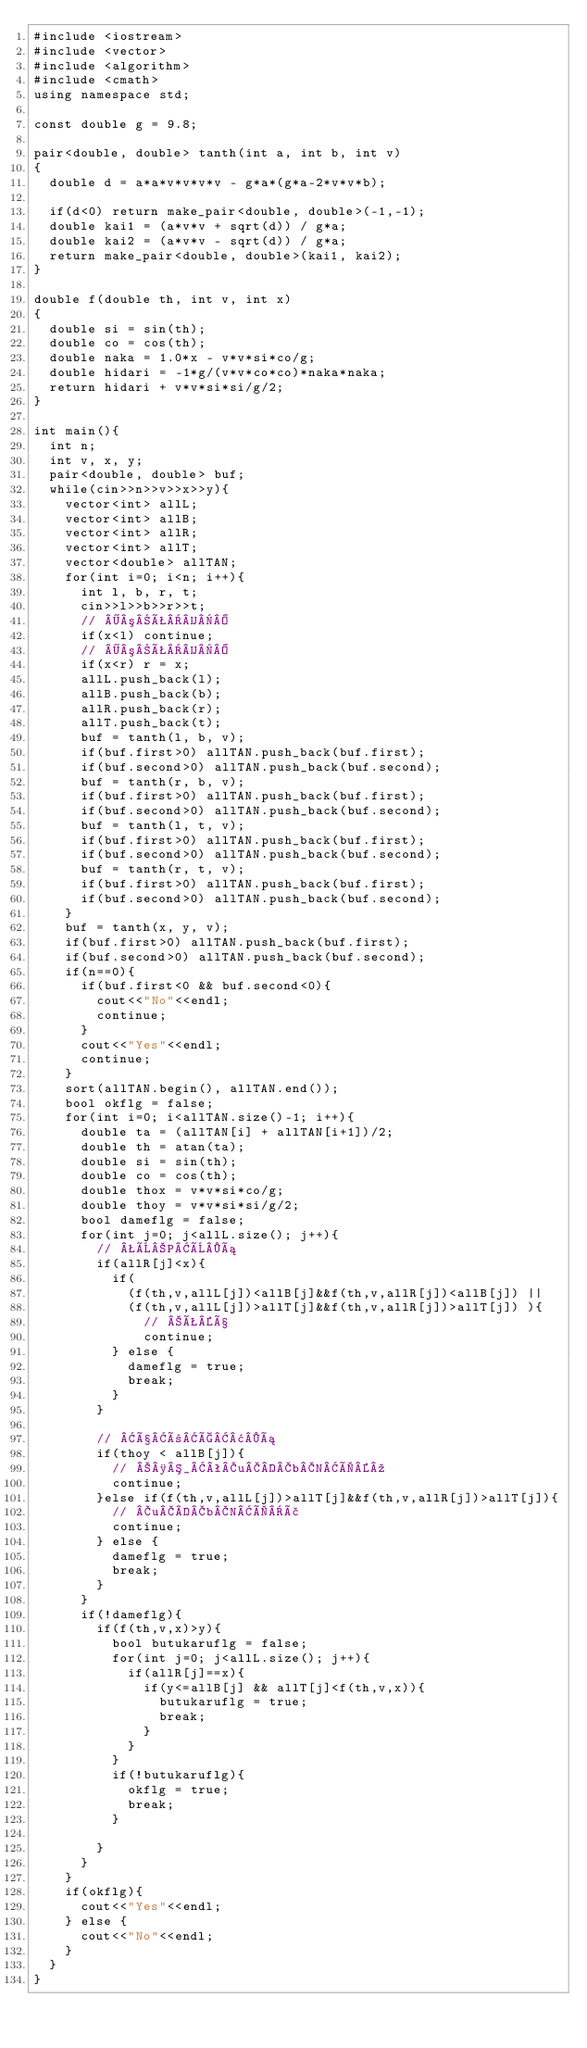<code> <loc_0><loc_0><loc_500><loc_500><_C++_>#include <iostream>
#include <vector>
#include <algorithm>
#include <cmath>
using namespace std;

const double g = 9.8;

pair<double, double> tanth(int a, int b, int v)
{
	double d = a*a*v*v*v*v - g*a*(g*a-2*v*v*b);

	if(d<0) return make_pair<double, double>(-1,-1);
	double kai1 = (a*v*v + sqrt(d)) / g*a;
	double kai2 = (a*v*v - sqrt(d)) / g*a;
	return make_pair<double, double>(kai1, kai2);
}

double f(double th, int v, int x)
{
	double si = sin(th);
	double co = cos(th);
	double naka = 1.0*x - v*v*si*co/g;
	double hidari = -1*g/(v*v*co*co)*naka*naka;
	return hidari + v*v*si*si/g/2;
}

int main(){
	int n;
	int v, x, y;
	pair<double, double> buf;
	while(cin>>n>>v>>x>>y){
		vector<int> allL;
		vector<int> allB;
		vector<int> allR;
		vector<int> allT;
		vector<double> allTAN;
		for(int i=0; i<n; i++){
			int l, b, r, t;
			cin>>l>>b>>r>>t;
			// ³Ê
			if(x<l) continue;
			// ³Ê
			if(x<r) r = x;
			allL.push_back(l);
			allB.push_back(b);
			allR.push_back(r);
			allT.push_back(t);
			buf = tanth(l, b, v);
			if(buf.first>0) allTAN.push_back(buf.first);
			if(buf.second>0) allTAN.push_back(buf.second);
			buf = tanth(r, b, v);
			if(buf.first>0) allTAN.push_back(buf.first);
			if(buf.second>0) allTAN.push_back(buf.second);
			buf = tanth(l, t, v);
			if(buf.first>0) allTAN.push_back(buf.first);
			if(buf.second>0) allTAN.push_back(buf.second);
			buf = tanth(r, t, v);
			if(buf.first>0) allTAN.push_back(buf.first);
			if(buf.second>0) allTAN.push_back(buf.second);
		}
		buf = tanth(x, y, v);
		if(buf.first>0) allTAN.push_back(buf.first);
		if(buf.second>0) allTAN.push_back(buf.second);
		if(n==0){
			if(buf.first<0 && buf.second<0){
				cout<<"No"<<endl;
				continue;
			}
			cout<<"Yes"<<endl;
			continue;
		} 
		sort(allTAN.begin(), allTAN.end());
		bool okflg = false;
		for(int i=0; i<allTAN.size()-1; i++){
			double ta = (allTAN[i] + allTAN[i+1])/2;
			double th = atan(ta);
			double si = sin(th);
			double co = cos(th);
			double thox = v*v*si*co/g;
			double thoy = v*v*si*si/g/2;
			bool dameflg = false;
			for(int j=0; j<allL.size(); j++){
				// ÈPÈá
				if(allR[j]<x){
					if(
						(f(th,v,allL[j])<allB[j]&&f(th,v,allR[j])<allB[j]) ||
						(f(th,v,allL[j])>allT[j]&&f(th,v,allR[j])>allT[j]) ){
							// Êß
							continue;
					} else {
						dameflg = true;
						break;
					}
				}

				// ßñÇ¢á
				if(thoy < allB[j]){
					// ¸_ªubNÌº
					continue;
				}else if(f(th,v,allL[j])>allT[j]&&f(th,v,allR[j])>allT[j]){
					// ubNÌã
					continue;
				} else {
					dameflg = true;
					break;
				}
			}
			if(!dameflg){
				if(f(th,v,x)>y){
					bool butukaruflg = false;
					for(int j=0; j<allL.size(); j++){
						if(allR[j]==x){
							if(y<=allB[j] && allT[j]<f(th,v,x)){
								butukaruflg = true;
								break;
							}
						}
					}
					if(!butukaruflg){
						okflg = true;
						break;
					}

				}
			}
		}
		if(okflg){
			cout<<"Yes"<<endl;
		} else {
			cout<<"No"<<endl;
		}
	}
}</code> 